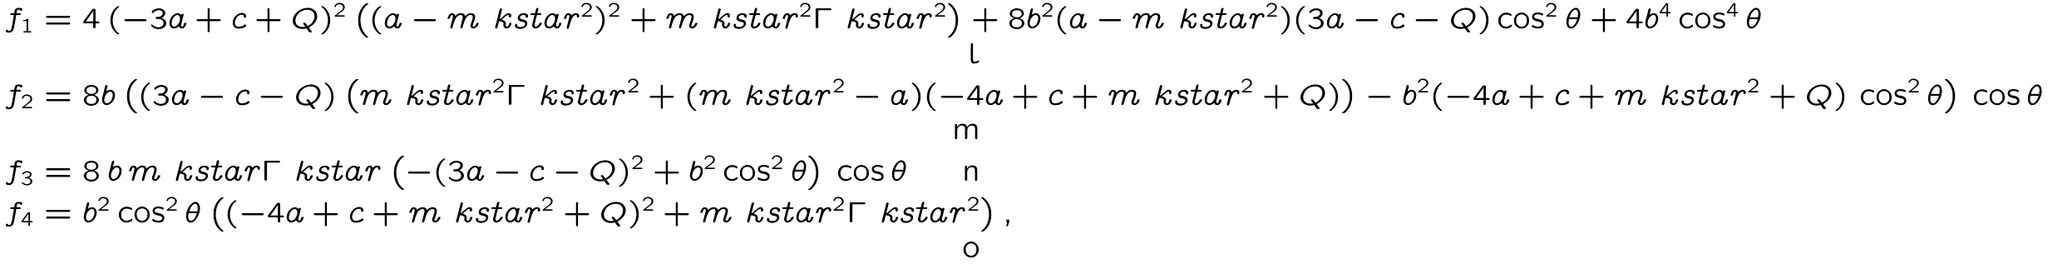Convert formula to latex. <formula><loc_0><loc_0><loc_500><loc_500>f _ { 1 } & = 4 \, ( - 3 a + c + Q ) ^ { 2 } \left ( ( a - m _ { \ } k s t a r ^ { 2 } ) ^ { 2 } + m _ { \ } k s t a r ^ { 2 } \Gamma _ { \ } k s t a r ^ { 2 } \right ) + 8 b ^ { 2 } ( a - m _ { \ } k s t a r ^ { 2 } ) ( 3 a - c - Q ) \cos ^ { 2 } \theta + 4 b ^ { 4 } \cos ^ { 4 } \theta \\ f _ { 2 } & = 8 b \left ( ( 3 a - c - Q ) \left ( m _ { \ } k s t a r ^ { 2 } \Gamma _ { \ } k s t a r ^ { 2 } + ( m _ { \ } k s t a r ^ { 2 } - a ) ( - 4 a + c + m _ { \ } k s t a r ^ { 2 } + Q ) \right ) - b ^ { 2 } ( - 4 a + c + m _ { \ } k s t a r ^ { 2 } + Q ) \, \cos ^ { 2 } \theta \right ) \, \cos \theta \\ f _ { 3 } & = 8 \, b \, m _ { \ } k s t a r \Gamma _ { \ } k s t a r \left ( - ( 3 a - c - Q ) ^ { 2 } + b ^ { 2 } \cos ^ { 2 } \theta \right ) \, \cos \theta \\ f _ { 4 } & = b ^ { 2 } \cos ^ { 2 } \theta \left ( ( - 4 a + c + m _ { \ } k s t a r ^ { 2 } + Q ) ^ { 2 } + m _ { \ } k s t a r ^ { 2 } \Gamma _ { \ } k s t a r ^ { 2 } \right ) ,</formula> 